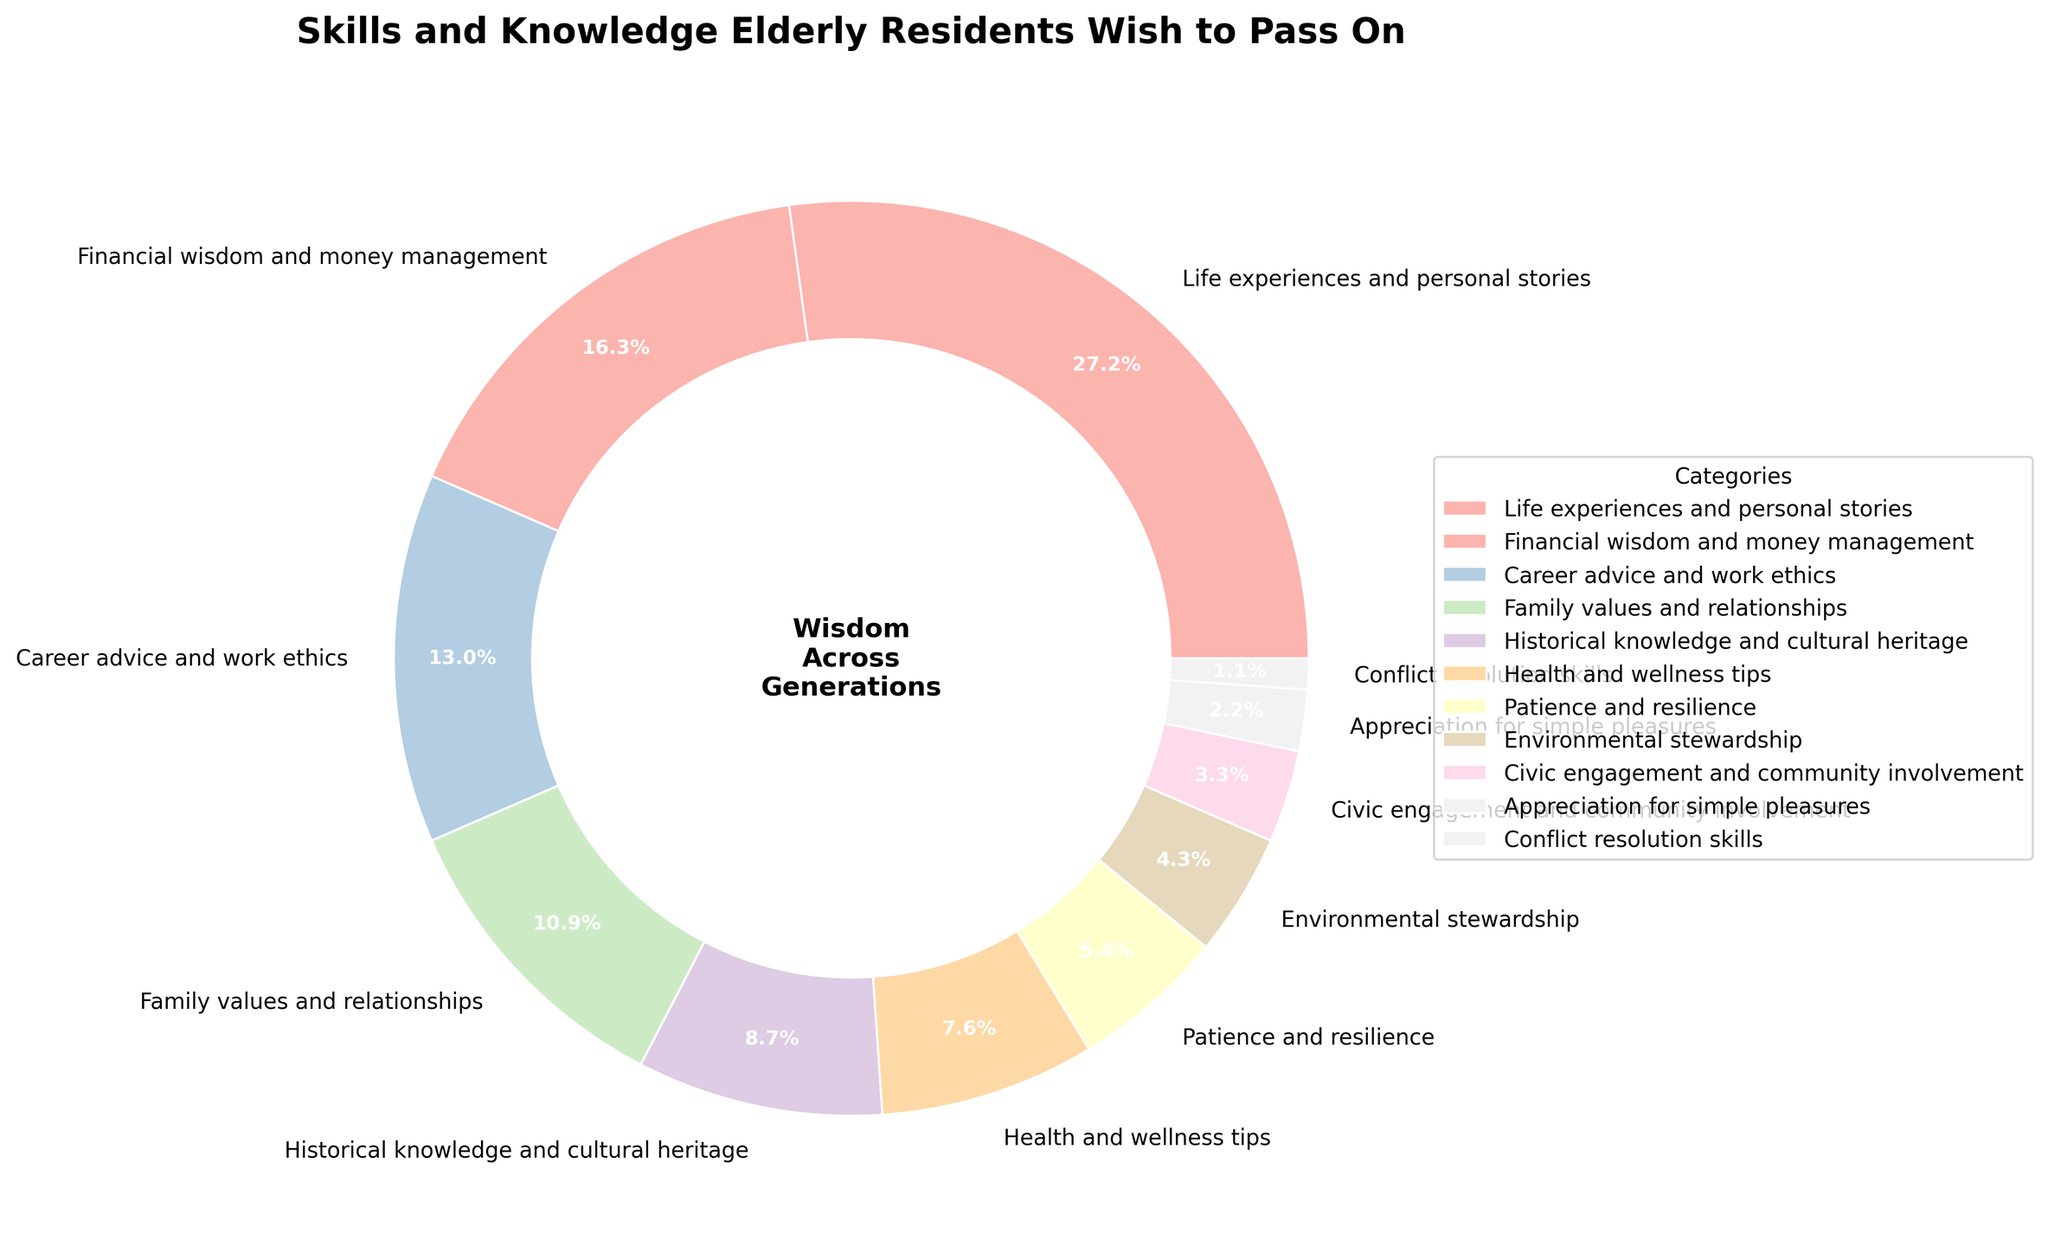What category has the largest percentage of skills and knowledge elderly residents wish to pass on? The figure shows a pie chart with different segments representing the percentages of various skills and knowledge categories. The largest segment, visually taking up the most space, is labeled "Life experiences and personal stories" with 25%.
Answer: Life experiences and personal stories Which category has a higher percentage: Financial wisdom and money management or Historical knowledge and cultural heritage? First, identify the segments for "Financial wisdom and money management" and "Historical knowledge and cultural heritage" in the pie chart. The "Financial wisdom and money management" segment is 15%, while the "Historical knowledge and cultural heritage" segment is 8%. The larger percentage is 15%.
Answer: Financial wisdom and money management What is the combined percentage of Health and wellness tips, Patience and resilience, and Civic engagement and community involvement? Locate the segments for "Health and wellness tips" (7%), "Patience and resilience" (5%), and "Civic engagement and community involvement" (3%) and add them together: 7% + 5% + 3% = 15%.
Answer: 15% Which skill category is depicted with the smallest segment in the pie chart? Identify the smallest segment visually in the pie chart, which corresponds to "Conflict resolution skills" with 1%.
Answer: Conflict resolution skills How do the combined percentages of Family values and relationships and Environmental stewardship compare to Career advice and work ethics? First, find the percentages for "Family values and relationships" (10%) and "Environmental stewardship" (4%). Adding them: 10% + 4% = 14%. The percentage for "Career advice and work ethics" is 12%. Comparing 14% to 12%, the combined percentage of the first two categories is greater.
Answer: Combined percentage is greater What percentage of the pie chart is attributed to skills related to financial or career advice? Locate the segments for "Financial wisdom and money management" (15%) and for "Career advice and work ethics" (12%). Add them together: 15% + 12% = 27%.
Answer: 27% Which three categories have the smallest percentages and what's their total? Locate the three smallest segments: "Appreciation for simple pleasures" (2%), "Conflict resolution skills" (1%), "Civic engagement and community involvement" (3%). Add them together: 2% + 1% + 3% = 6%.
Answer: 6% If you combined the percentages for Environmental stewardship and Civic engagement and community involvement, would it surpass Health and wellness tips? Find the percentages for "Environmental stewardship" (4%) and "Civic engagement and community involvement" (3%) and add them: 4% + 3% = 7%. The percentage for "Health and wellness tips" is also 7%. Comparing, they are equal.
Answer: Equal What visual attributes help identify the importance of Life experiences and personal stories in the pie chart? The segment for "Life experiences and personal stories" is the largest, making it visually dominant. It takes up a quarter of the pie chart (25%), indicating it's the most important category. Additionally, the segment is prominently placed to catch the viewer's eye easily.
Answer: Largest segment 